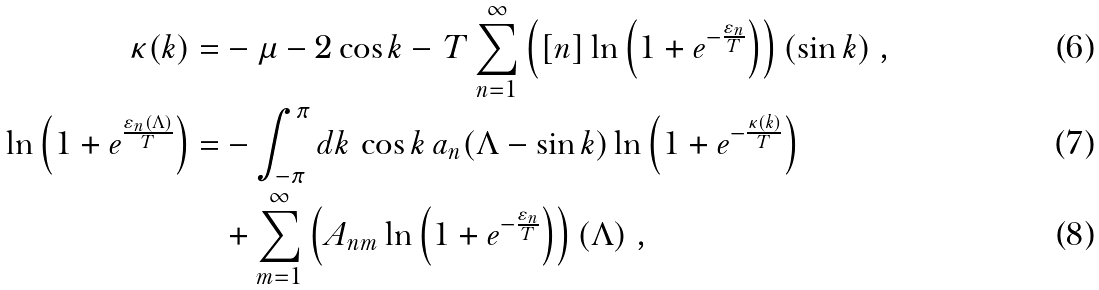Convert formula to latex. <formula><loc_0><loc_0><loc_500><loc_500>\kappa ( k ) = & - \mu - 2 \cos k - \, T \sum _ { n = 1 } ^ { \infty } \left ( [ n ] \ln \left ( 1 + e ^ { - \frac { \varepsilon _ { n } } { T } } \right ) \right ) ( \sin k ) \ , \\ \ln \left ( 1 + e ^ { \frac { \varepsilon _ { n } ( \Lambda ) } { T } } \right ) = & - \int _ { - \pi } ^ { \pi } d k \, \cos k \, a _ { n } ( \Lambda - \sin k ) \ln \left ( 1 + e ^ { - \frac { \kappa ( k ) } { T } } \right ) \\ & + \sum _ { m = 1 } ^ { \infty } \left ( A _ { n m } \ln \left ( 1 + e ^ { - \frac { \varepsilon _ { n } } { T } } \right ) \right ) ( \Lambda ) \ ,</formula> 